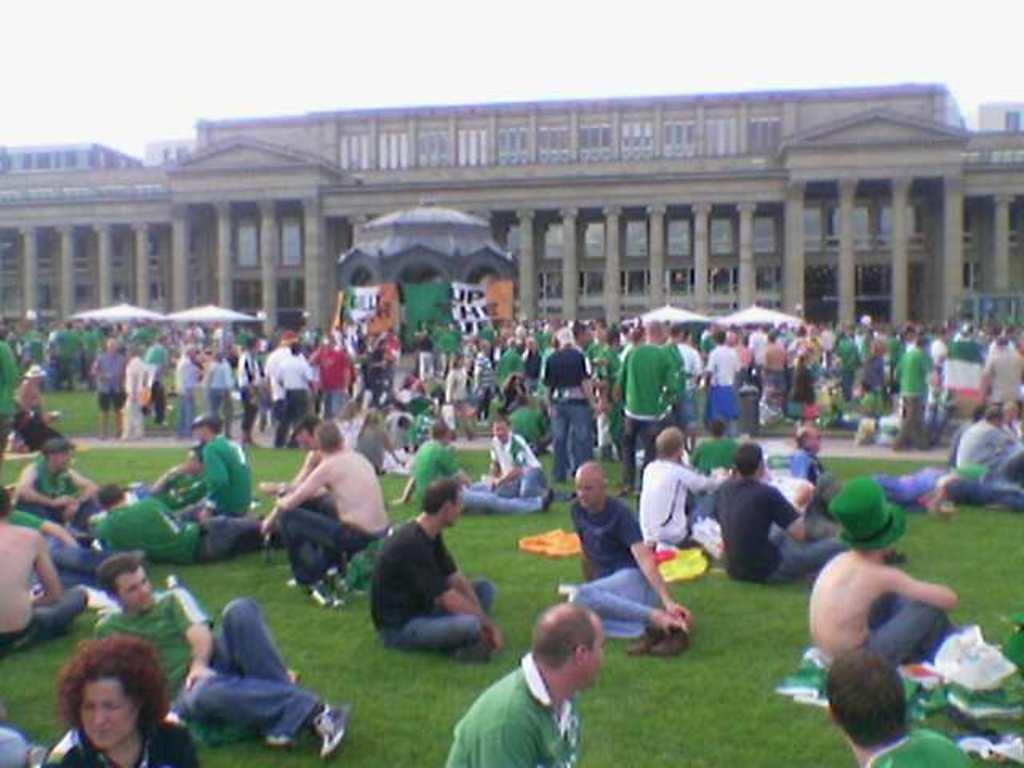Could you give a brief overview of what you see in this image? In this image we can see many people. Some are sitting and some are standing. In the background there is a building with pillars. Also there is sky. And there are tents. 